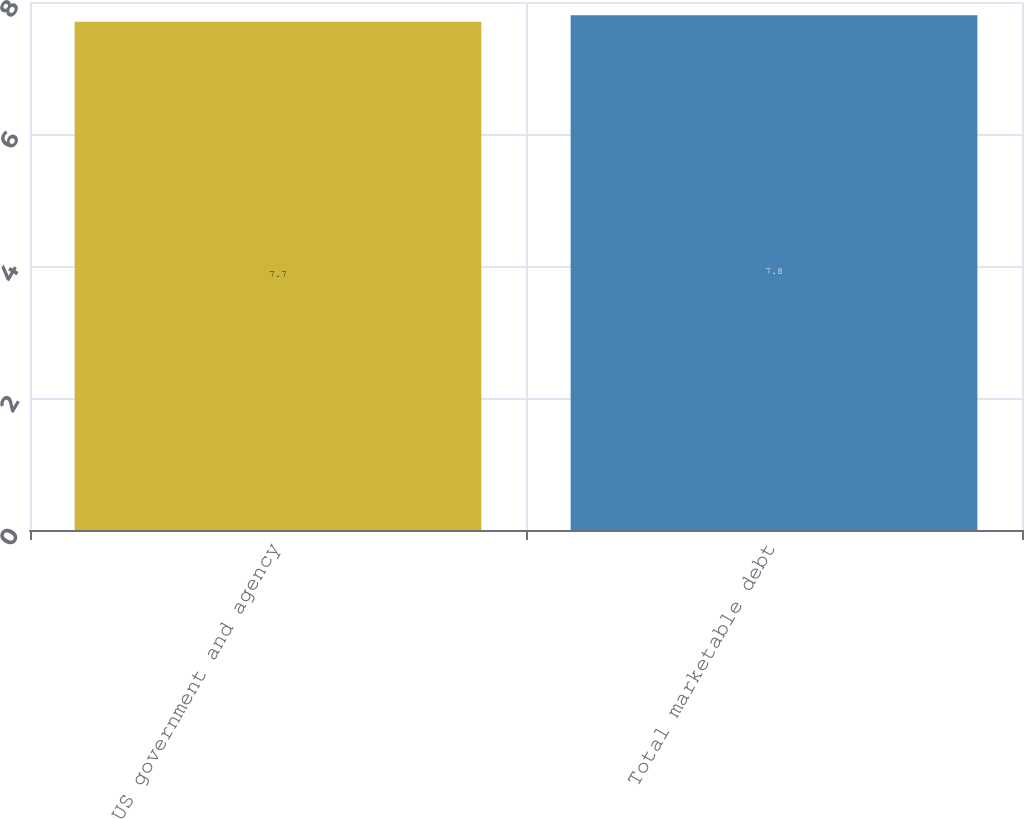Convert chart to OTSL. <chart><loc_0><loc_0><loc_500><loc_500><bar_chart><fcel>US government and agency<fcel>Total marketable debt<nl><fcel>7.7<fcel>7.8<nl></chart> 